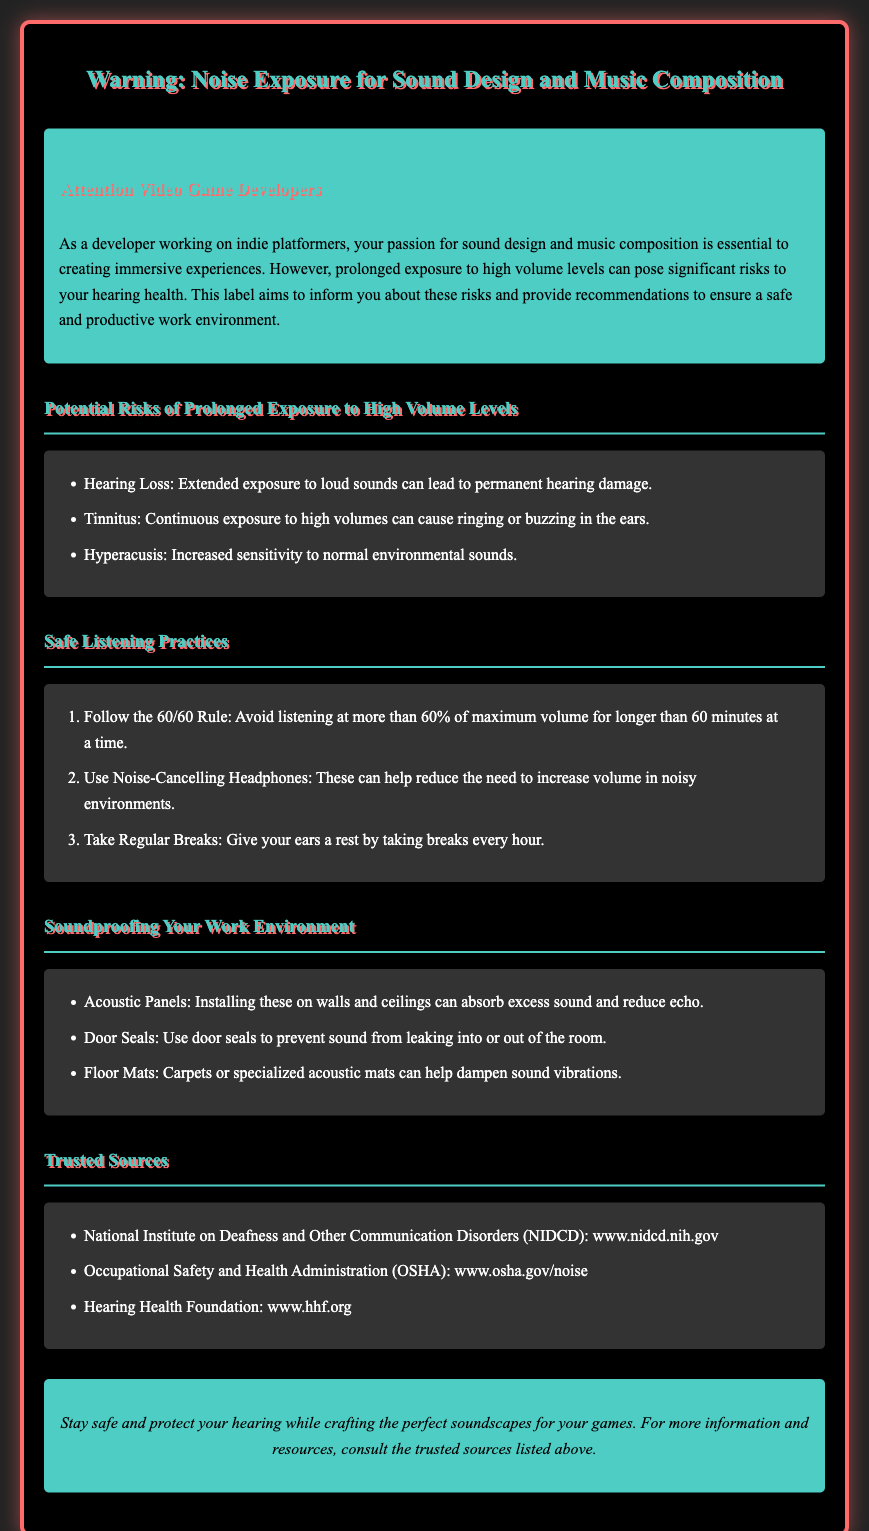What is the primary audience for this warning label? The document specifically addresses video game developers, emphasizing their role in sound design and music composition.
Answer: Video Game Developers What is the 60/60 Rule? The document states that the 60/60 Rule is to avoid listening at more than 60% of maximum volume for longer than 60 minutes at a time.
Answer: 60% of maximum volume for 60 minutes What are potential risks of prolonged exposure to high volume levels? The document lists hearing loss, tinnitus, and hyperacusis as risks associated with prolonged exposure to high volume levels.
Answer: Hearing Loss, Tinnitus, Hyperacusis What type of headphones are recommended for safe listening? The document suggests using noise-cancelling headphones to help reduce the need to increase volume in noisy environments.
Answer: Noise-Cancelling Headphones How many safe listening practices are outlined in the document? The document lists three safe listening practices to follow for sound safety.
Answer: Three What is one method for soundproofing a work environment mentioned in the document? The document recommends installing acoustic panels to absorb excess sound and reduce echo.
Answer: Acoustic Panels Which organization provides information on noise exposure? The trusted source includes the National Institute on Deafness and Other Communication Disorders (NIDCD).
Answer: NIDCD What should developers do every hour according to the safe listening practices? The document advises taking regular breaks every hour to give ears a rest.
Answer: Take Regular Breaks 